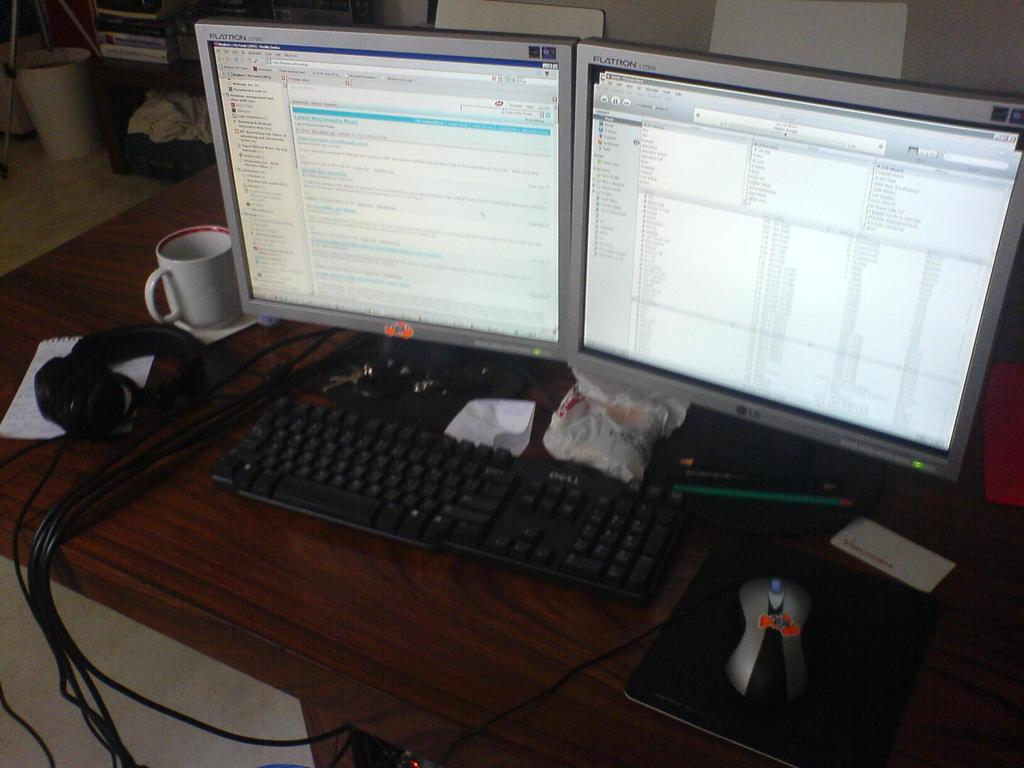<image>
Share a concise interpretation of the image provided. Two Flatron computer screens mounted side by side on a desk. 